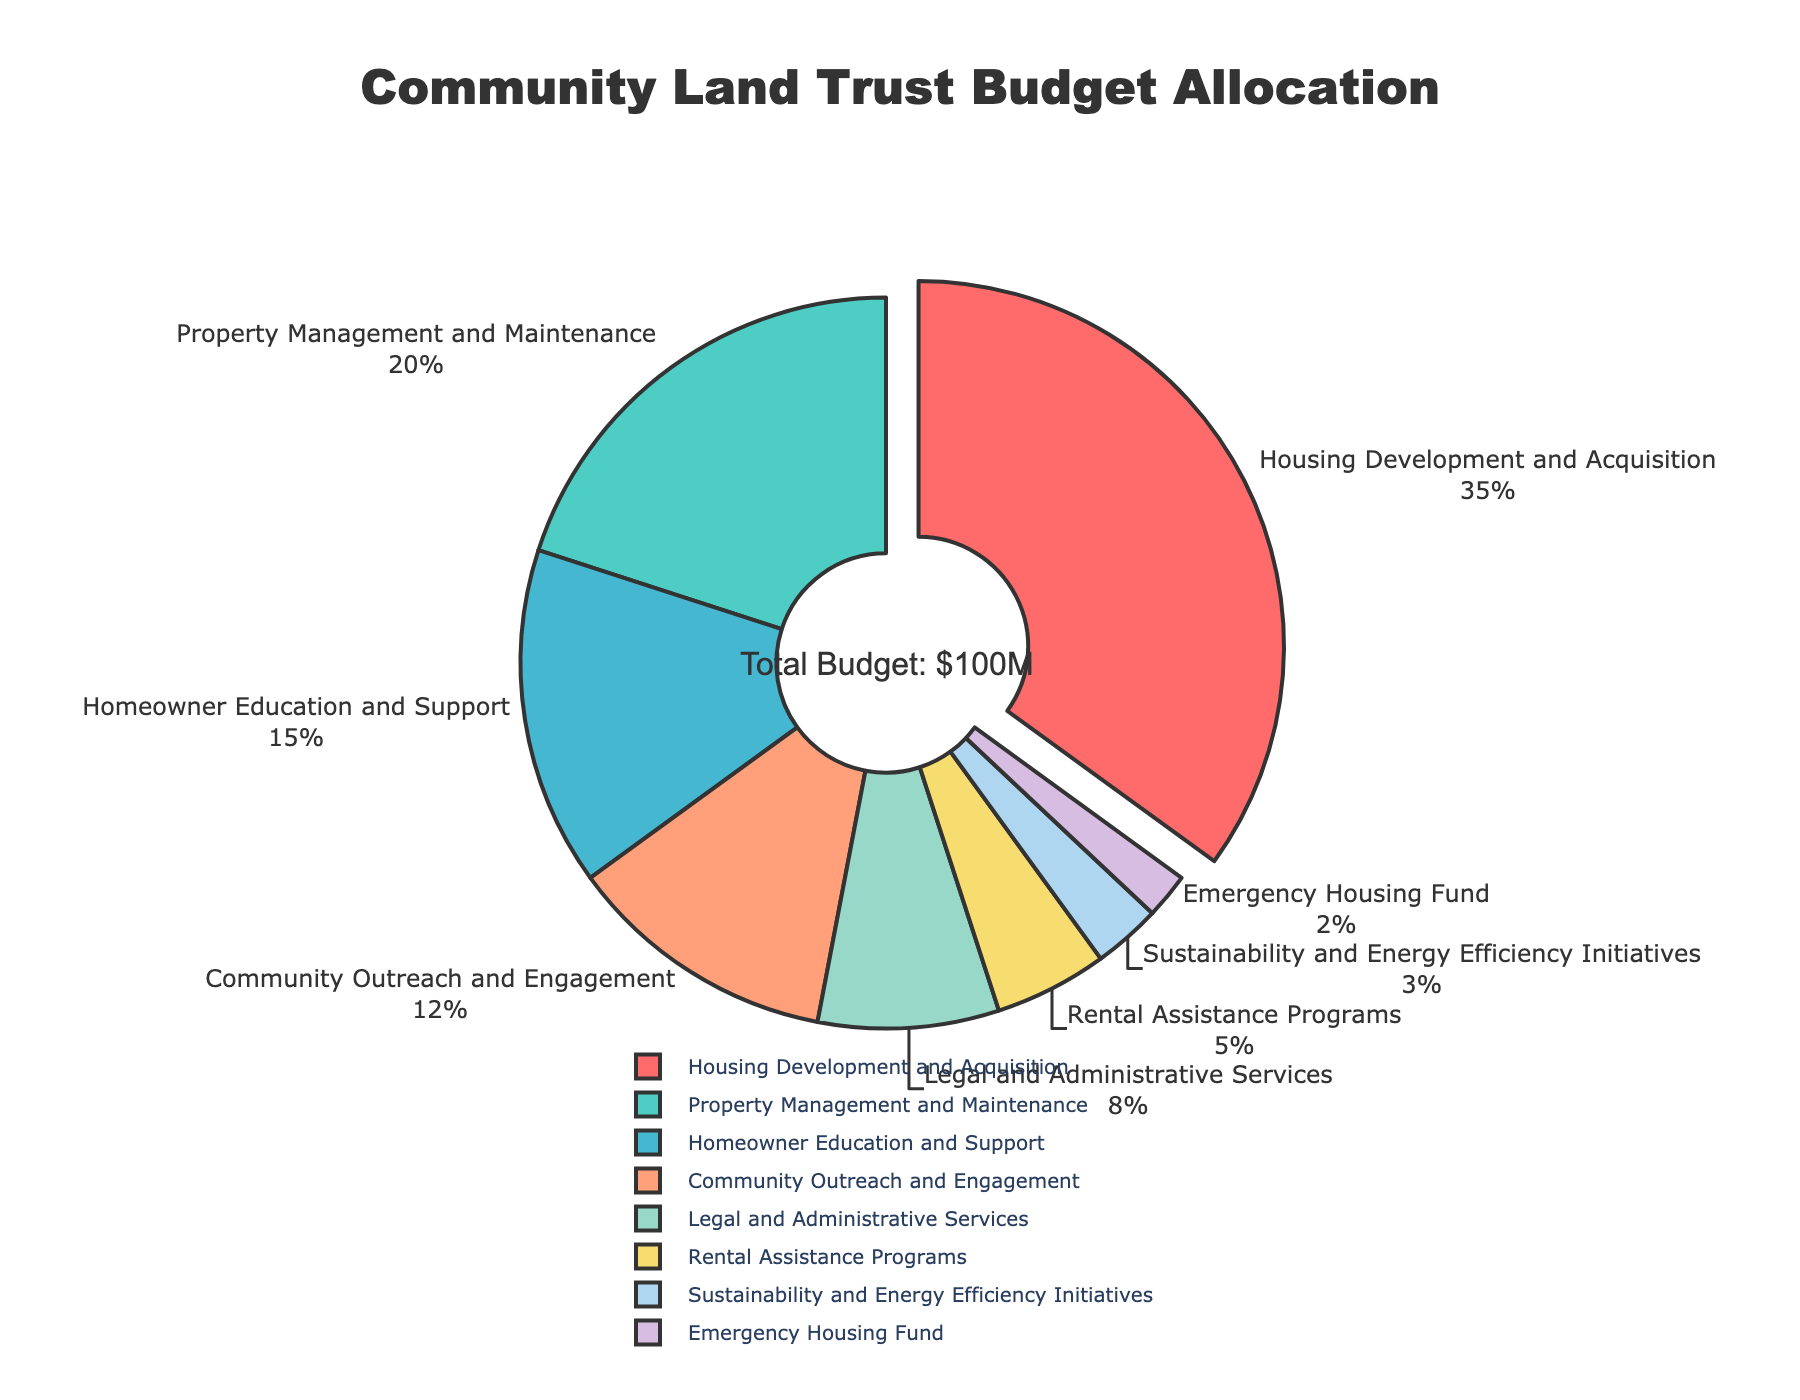What percentage of the total budget is allocated to the Housing Development and Acquisition program? The pie chart shows the percentage of the budget for each program. For the Housing Development and Acquisition program, it shows 35%.
Answer: 35% Which program has the smallest budget allocation? By examining all sections of the pie chart, you can identify the smallest slice, which is for the Emergency Housing Fund.
Answer: Emergency Housing Fund How much more budget (in percentage points) is allocated to Property Management and Maintenance compared to Rental Assistance Programs? Property Management and Maintenance has 20% while Rental Assistance Programs have 5%. The difference is 20% - 5% = 15%.
Answer: 15% What visual attribute distinguishes the Housing Development and Acquisition section in the pie chart? The Housing Development and Acquisition section is slightly pulled out from the pie chart to emphasize its significance.
Answer: Pulled out What is the sum of the budgets allocated to Homeowner Education and Support, and Community Outreach and Engagement programs? Homeowner Education and Support has 15%, and Community Outreach and Engagement has 12%. The sum is 15% + 12% = 27%.
Answer: 27% Is the budget allocation for Sustainability and Energy Efficiency Initiatives greater than the Emergency Housing Fund? The pie chart shows that Sustainability and Energy Efficiency Initiatives have 3%, while the Emergency Housing Fund has 2%. 3% is greater than 2%.
Answer: Yes Which program has the second-largest budget allocation? The pie chart shows the percentages, and the second-largest slice is for Property Management and Maintenance with 20%.
Answer: Property Management and Maintenance By how many percentage points does the budget for Legal and Administrative Services exceed Rental Assistance Programs? Legal and Administrative Services has 8%, and Rental Assistance Programs have 5%. The difference is 8% - 5% = 3%.
Answer: 3% What is the combined budget allocation of all the programs except Housing Development and Acquisition? The total budget is 100%, and Housing Development and Acquisition has 35%. Thus, the combined budget of the remaining programs is 100% - 35% = 65%.
Answer: 65% What is the allocated budget (in percentage) for programs related to direct housing support (including Housing Development and Acquisition, Property Management and Maintenance, and Rental Assistance Programs)? Housing Development and Acquisition has 35%, Property Management and Maintenance has 20%, and Rental Assistance Programs have 5%. The sum is 35% + 20% + 5% = 60%.
Answer: 60% 